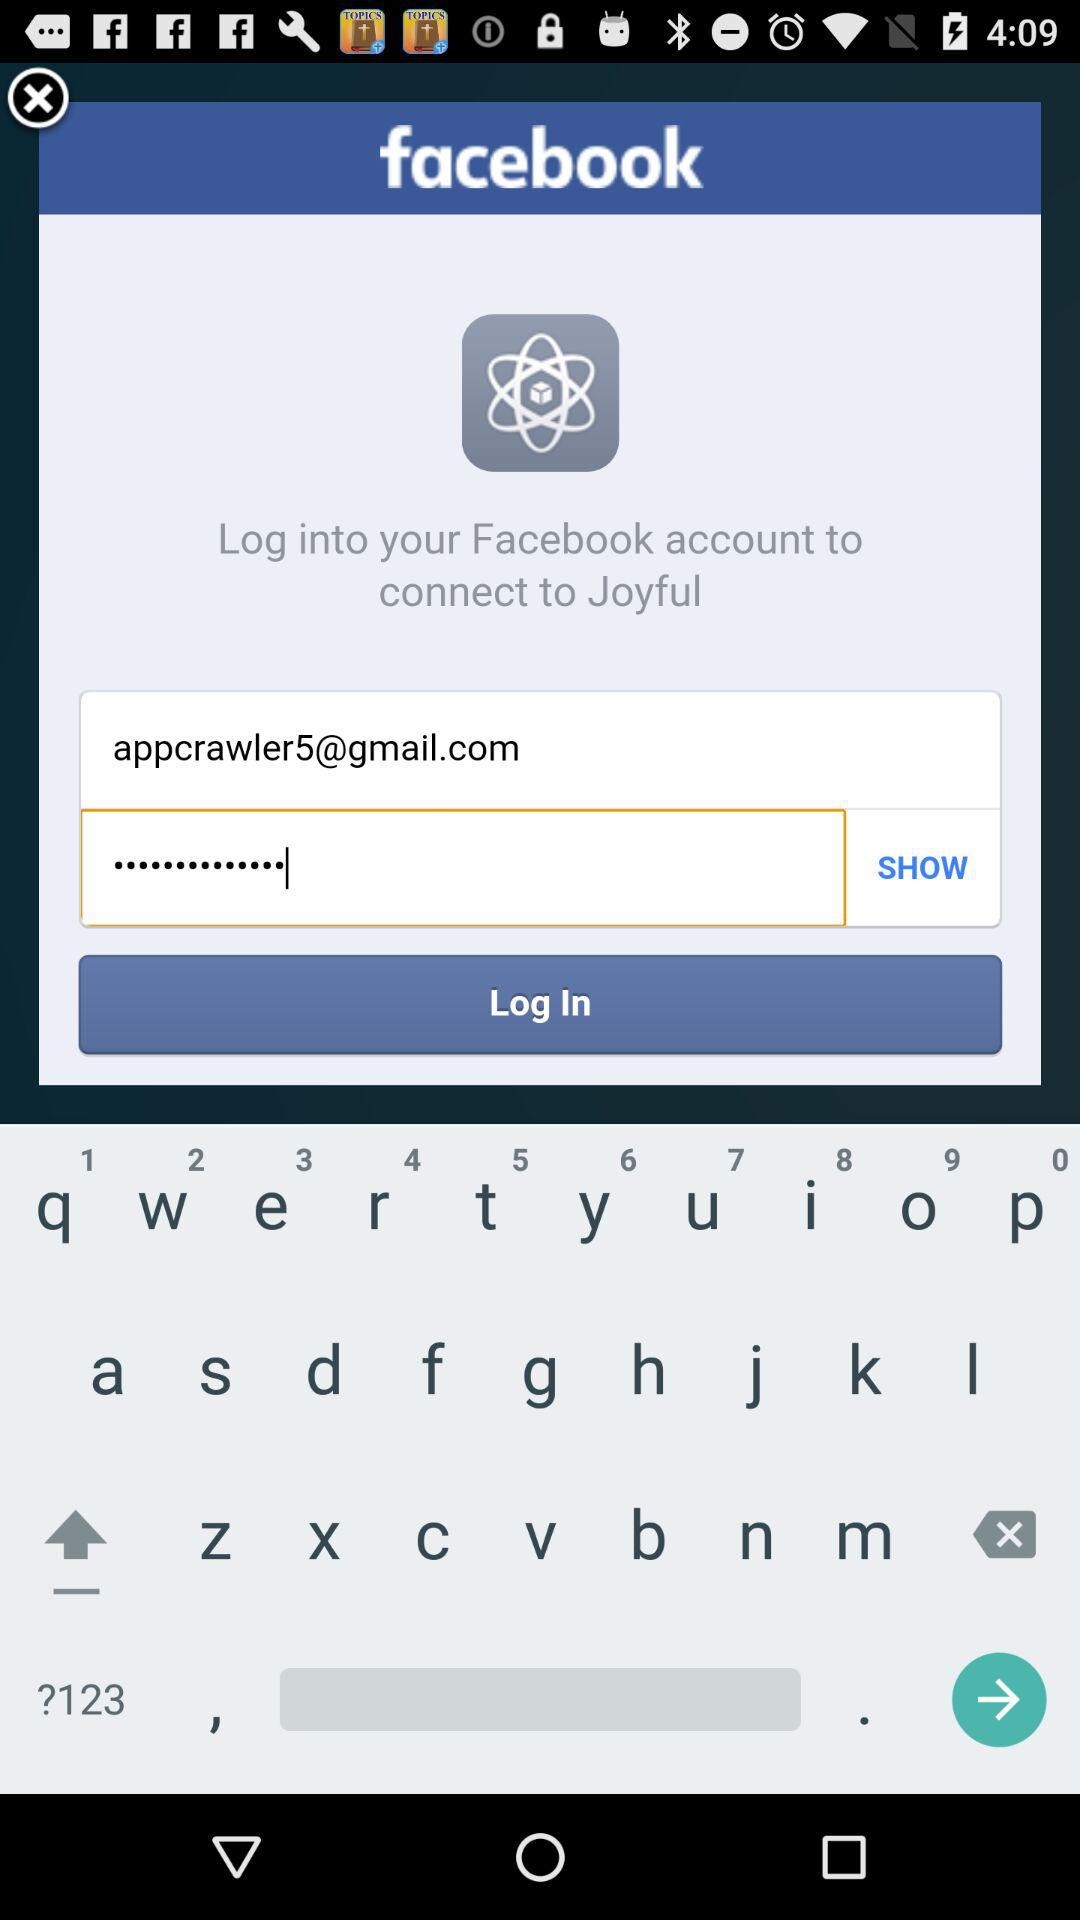What's the name of the account that can be used to connect to "Joyful"? The name of the account is "Facebook". 